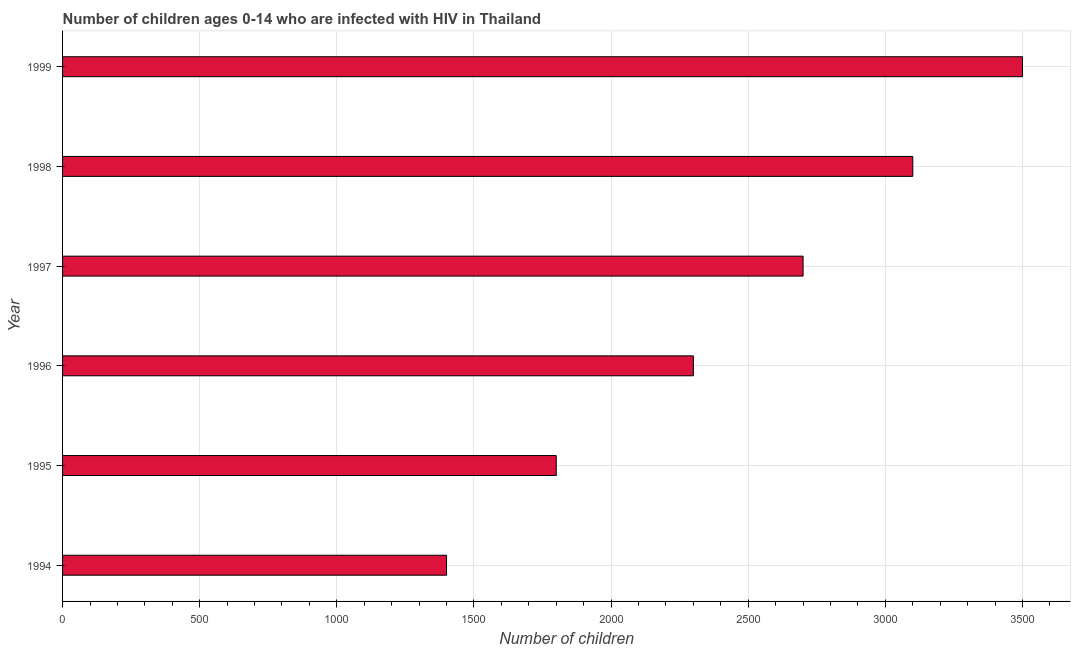What is the title of the graph?
Offer a terse response. Number of children ages 0-14 who are infected with HIV in Thailand. What is the label or title of the X-axis?
Provide a succinct answer. Number of children. What is the number of children living with hiv in 1998?
Provide a short and direct response. 3100. Across all years, what is the maximum number of children living with hiv?
Offer a very short reply. 3500. Across all years, what is the minimum number of children living with hiv?
Offer a very short reply. 1400. In which year was the number of children living with hiv minimum?
Your answer should be compact. 1994. What is the sum of the number of children living with hiv?
Make the answer very short. 1.48e+04. What is the difference between the number of children living with hiv in 1997 and 1999?
Offer a very short reply. -800. What is the average number of children living with hiv per year?
Give a very brief answer. 2466. What is the median number of children living with hiv?
Your answer should be very brief. 2500. Do a majority of the years between 1999 and 1998 (inclusive) have number of children living with hiv greater than 1700 ?
Keep it short and to the point. No. What is the ratio of the number of children living with hiv in 1997 to that in 1999?
Offer a terse response. 0.77. Is the number of children living with hiv in 1994 less than that in 1997?
Ensure brevity in your answer.  Yes. Is the sum of the number of children living with hiv in 1995 and 1996 greater than the maximum number of children living with hiv across all years?
Keep it short and to the point. Yes. What is the difference between the highest and the lowest number of children living with hiv?
Ensure brevity in your answer.  2100. In how many years, is the number of children living with hiv greater than the average number of children living with hiv taken over all years?
Your response must be concise. 3. Are all the bars in the graph horizontal?
Make the answer very short. Yes. What is the difference between two consecutive major ticks on the X-axis?
Offer a very short reply. 500. What is the Number of children in 1994?
Provide a succinct answer. 1400. What is the Number of children in 1995?
Offer a terse response. 1800. What is the Number of children of 1996?
Provide a short and direct response. 2300. What is the Number of children of 1997?
Offer a very short reply. 2700. What is the Number of children of 1998?
Offer a terse response. 3100. What is the Number of children of 1999?
Your response must be concise. 3500. What is the difference between the Number of children in 1994 and 1995?
Give a very brief answer. -400. What is the difference between the Number of children in 1994 and 1996?
Give a very brief answer. -900. What is the difference between the Number of children in 1994 and 1997?
Give a very brief answer. -1300. What is the difference between the Number of children in 1994 and 1998?
Offer a terse response. -1700. What is the difference between the Number of children in 1994 and 1999?
Make the answer very short. -2100. What is the difference between the Number of children in 1995 and 1996?
Offer a very short reply. -500. What is the difference between the Number of children in 1995 and 1997?
Provide a succinct answer. -900. What is the difference between the Number of children in 1995 and 1998?
Your response must be concise. -1300. What is the difference between the Number of children in 1995 and 1999?
Your response must be concise. -1700. What is the difference between the Number of children in 1996 and 1997?
Make the answer very short. -400. What is the difference between the Number of children in 1996 and 1998?
Your answer should be compact. -800. What is the difference between the Number of children in 1996 and 1999?
Give a very brief answer. -1200. What is the difference between the Number of children in 1997 and 1998?
Your answer should be very brief. -400. What is the difference between the Number of children in 1997 and 1999?
Offer a very short reply. -800. What is the difference between the Number of children in 1998 and 1999?
Offer a very short reply. -400. What is the ratio of the Number of children in 1994 to that in 1995?
Your answer should be compact. 0.78. What is the ratio of the Number of children in 1994 to that in 1996?
Make the answer very short. 0.61. What is the ratio of the Number of children in 1994 to that in 1997?
Your response must be concise. 0.52. What is the ratio of the Number of children in 1994 to that in 1998?
Keep it short and to the point. 0.45. What is the ratio of the Number of children in 1995 to that in 1996?
Provide a short and direct response. 0.78. What is the ratio of the Number of children in 1995 to that in 1997?
Ensure brevity in your answer.  0.67. What is the ratio of the Number of children in 1995 to that in 1998?
Provide a succinct answer. 0.58. What is the ratio of the Number of children in 1995 to that in 1999?
Keep it short and to the point. 0.51. What is the ratio of the Number of children in 1996 to that in 1997?
Give a very brief answer. 0.85. What is the ratio of the Number of children in 1996 to that in 1998?
Offer a terse response. 0.74. What is the ratio of the Number of children in 1996 to that in 1999?
Give a very brief answer. 0.66. What is the ratio of the Number of children in 1997 to that in 1998?
Provide a succinct answer. 0.87. What is the ratio of the Number of children in 1997 to that in 1999?
Ensure brevity in your answer.  0.77. What is the ratio of the Number of children in 1998 to that in 1999?
Provide a succinct answer. 0.89. 